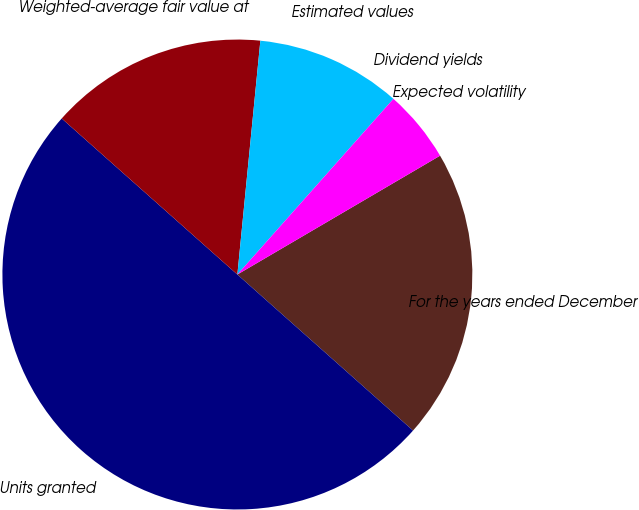<chart> <loc_0><loc_0><loc_500><loc_500><pie_chart><fcel>For the years ended December<fcel>Units granted<fcel>Weighted-average fair value at<fcel>Estimated values<fcel>Dividend yields<fcel>Expected volatility<nl><fcel>20.0%<fcel>50.0%<fcel>15.0%<fcel>10.0%<fcel>0.0%<fcel>5.0%<nl></chart> 